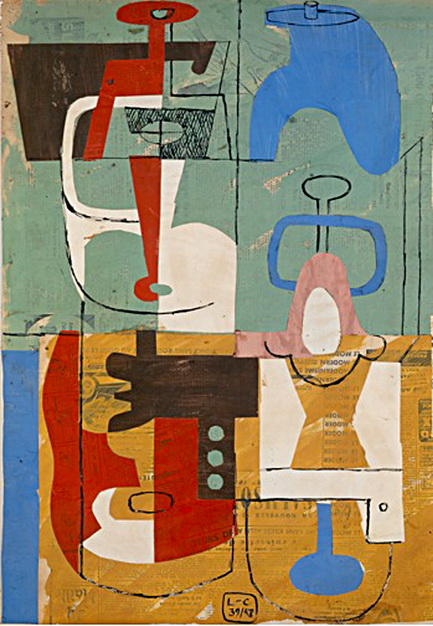How might this abstract artwork be incorporated into a modern-day advertising campaign? In a modern-day advertising campaign, this abstract artwork could serve as a striking visual element to capture the audience's attention. Its vibrant colors and dynamic composition would make it an excellent backdrop for advertisements promoting creativity, innovation, and artistic expression.

For example, a tech company could use this artwork to highlight the fusion of technology and art, emphasizing themes of originality and forward-thinking. The geometric shapes and varied color palette could be animated to showcase product features in a visually appealing manner, making the campaign both engaging and memorable.

Moreover, the artwork's abstract nature allows it to be versatile and adaptable to various product lines, from lifestyle brands to fashion and interior design. Its aesthetic appeal would resonate well with a diverse audience, making it a powerful tool for conveying the brand's message and values in a visually compelling way. 